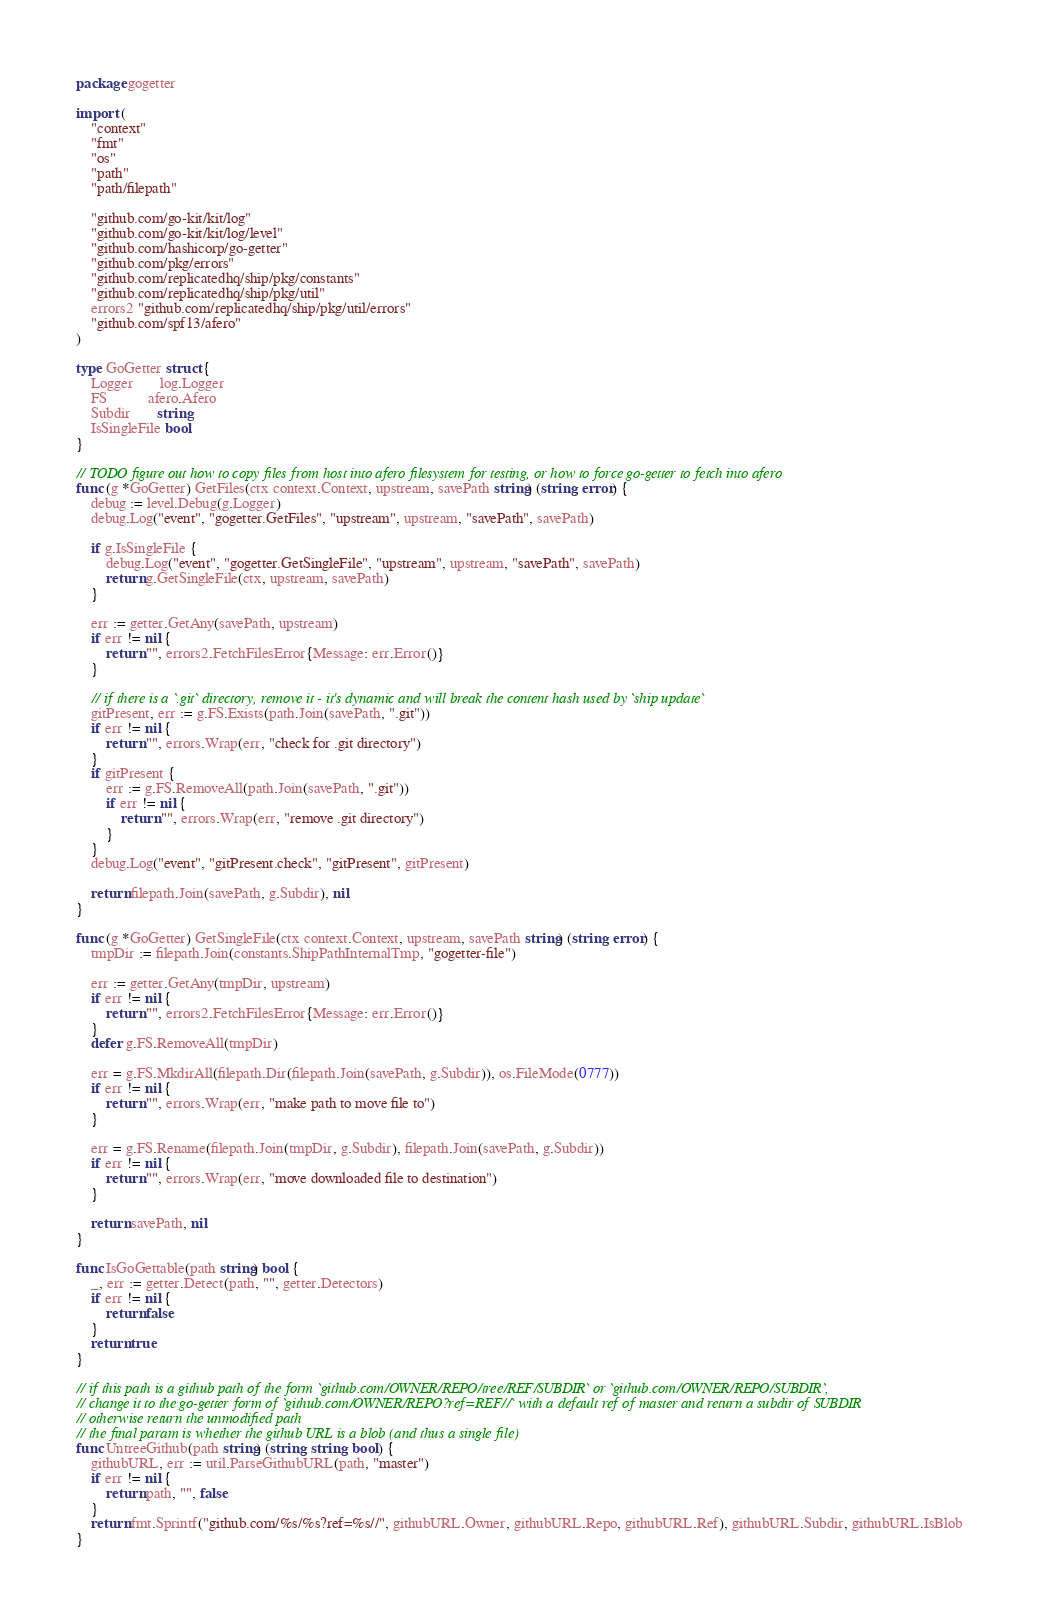Convert code to text. <code><loc_0><loc_0><loc_500><loc_500><_Go_>package gogetter

import (
	"context"
	"fmt"
	"os"
	"path"
	"path/filepath"

	"github.com/go-kit/kit/log"
	"github.com/go-kit/kit/log/level"
	"github.com/hashicorp/go-getter"
	"github.com/pkg/errors"
	"github.com/replicatedhq/ship/pkg/constants"
	"github.com/replicatedhq/ship/pkg/util"
	errors2 "github.com/replicatedhq/ship/pkg/util/errors"
	"github.com/spf13/afero"
)

type GoGetter struct {
	Logger       log.Logger
	FS           afero.Afero
	Subdir       string
	IsSingleFile bool
}

// TODO figure out how to copy files from host into afero filesystem for testing, or how to force go-getter to fetch into afero
func (g *GoGetter) GetFiles(ctx context.Context, upstream, savePath string) (string, error) {
	debug := level.Debug(g.Logger)
	debug.Log("event", "gogetter.GetFiles", "upstream", upstream, "savePath", savePath)

	if g.IsSingleFile {
		debug.Log("event", "gogetter.GetSingleFile", "upstream", upstream, "savePath", savePath)
		return g.GetSingleFile(ctx, upstream, savePath)
	}

	err := getter.GetAny(savePath, upstream)
	if err != nil {
		return "", errors2.FetchFilesError{Message: err.Error()}
	}

	// if there is a `.git` directory, remove it - it's dynamic and will break the content hash used by `ship update`
	gitPresent, err := g.FS.Exists(path.Join(savePath, ".git"))
	if err != nil {
		return "", errors.Wrap(err, "check for .git directory")
	}
	if gitPresent {
		err := g.FS.RemoveAll(path.Join(savePath, ".git"))
		if err != nil {
			return "", errors.Wrap(err, "remove .git directory")
		}
	}
	debug.Log("event", "gitPresent.check", "gitPresent", gitPresent)

	return filepath.Join(savePath, g.Subdir), nil
}

func (g *GoGetter) GetSingleFile(ctx context.Context, upstream, savePath string) (string, error) {
	tmpDir := filepath.Join(constants.ShipPathInternalTmp, "gogetter-file")

	err := getter.GetAny(tmpDir, upstream)
	if err != nil {
		return "", errors2.FetchFilesError{Message: err.Error()}
	}
	defer g.FS.RemoveAll(tmpDir)

	err = g.FS.MkdirAll(filepath.Dir(filepath.Join(savePath, g.Subdir)), os.FileMode(0777))
	if err != nil {
		return "", errors.Wrap(err, "make path to move file to")
	}

	err = g.FS.Rename(filepath.Join(tmpDir, g.Subdir), filepath.Join(savePath, g.Subdir))
	if err != nil {
		return "", errors.Wrap(err, "move downloaded file to destination")
	}

	return savePath, nil
}

func IsGoGettable(path string) bool {
	_, err := getter.Detect(path, "", getter.Detectors)
	if err != nil {
		return false
	}
	return true
}

// if this path is a github path of the form `github.com/OWNER/REPO/tree/REF/SUBDIR` or `github.com/OWNER/REPO/SUBDIR`,
// change it to the go-getter form of `github.com/OWNER/REPO?ref=REF//` with a default ref of master and return a subdir of SUBDIR
// otherwise return the unmodified path
// the final param is whether the github URL is a blob (and thus a single file)
func UntreeGithub(path string) (string, string, bool) {
	githubURL, err := util.ParseGithubURL(path, "master")
	if err != nil {
		return path, "", false
	}
	return fmt.Sprintf("github.com/%s/%s?ref=%s//", githubURL.Owner, githubURL.Repo, githubURL.Ref), githubURL.Subdir, githubURL.IsBlob
}
</code> 